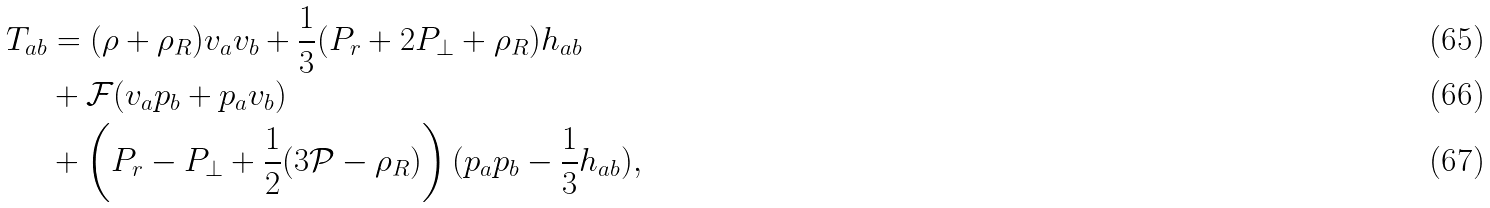<formula> <loc_0><loc_0><loc_500><loc_500>T _ { a b } & = ( \rho + \rho _ { R } ) v _ { a } v _ { b } + \frac { 1 } { 3 } ( P _ { r } + 2 P _ { \perp } + \rho _ { R } ) h _ { a b } \\ & + \mathcal { F } ( v _ { a } p _ { b } + p _ { a } v _ { b } ) \\ & + \left ( P _ { r } - P _ { \perp } + \frac { 1 } { 2 } ( 3 \mathcal { P } - \rho _ { R } ) \right ) ( p _ { a } p _ { b } - \frac { 1 } { 3 } h _ { a b } ) ,</formula> 